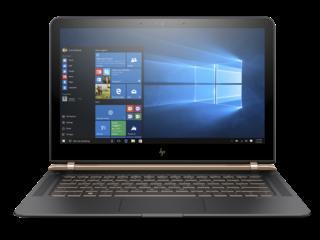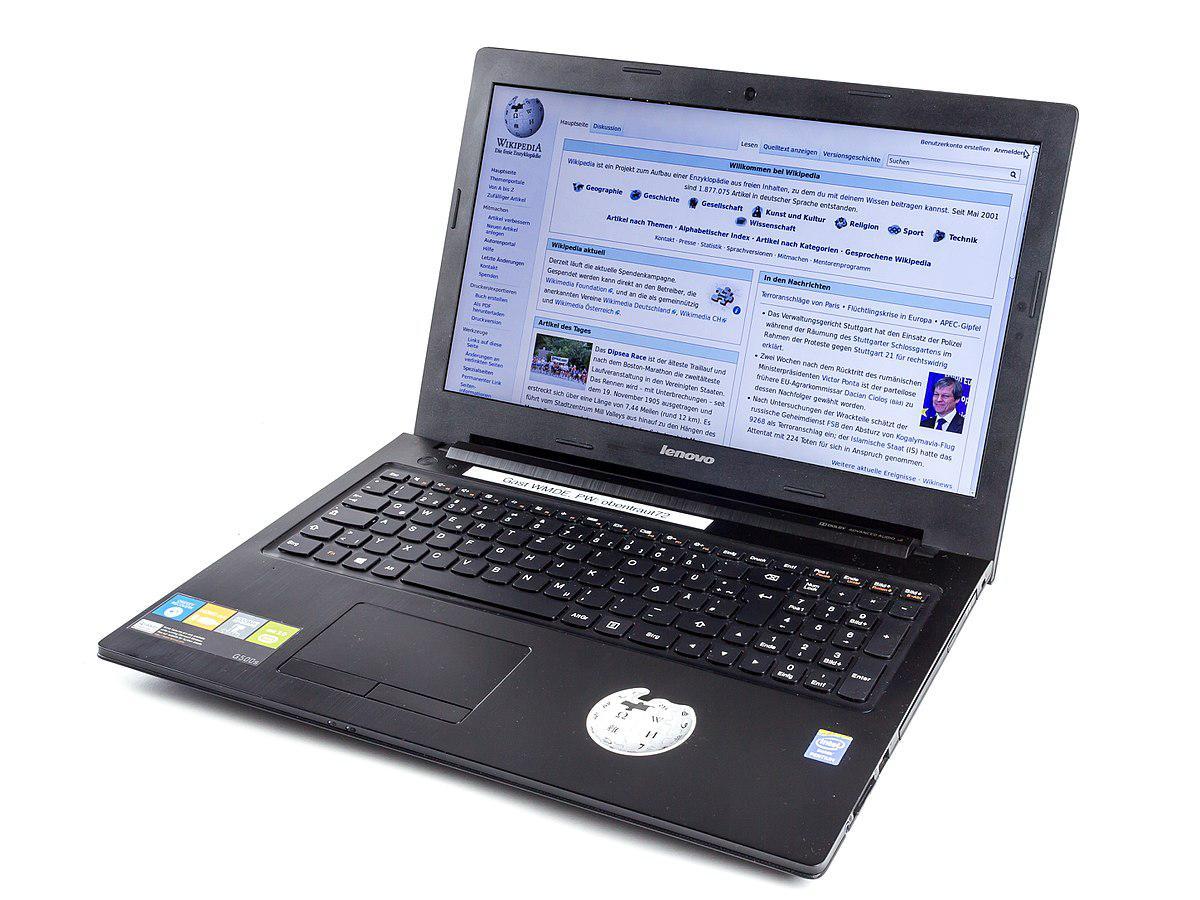The first image is the image on the left, the second image is the image on the right. For the images shown, is this caption "One of the images contains a laptop turned toward the right." true? Answer yes or no. No. 